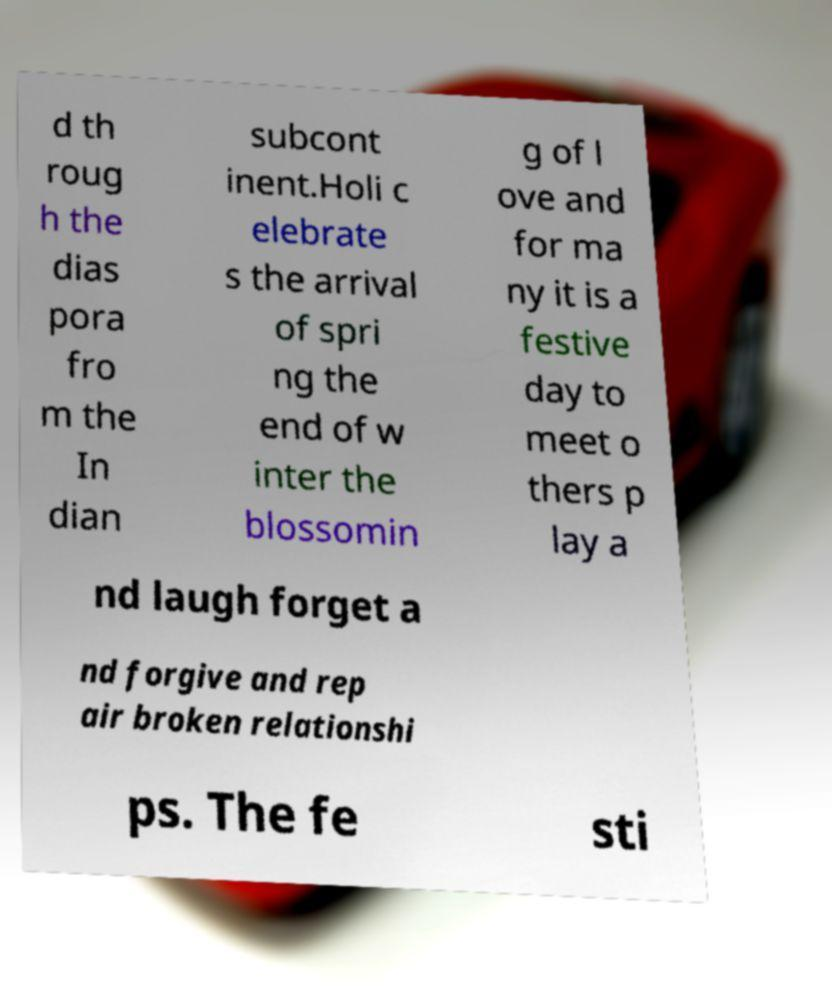I need the written content from this picture converted into text. Can you do that? d th roug h the dias pora fro m the In dian subcont inent.Holi c elebrate s the arrival of spri ng the end of w inter the blossomin g of l ove and for ma ny it is a festive day to meet o thers p lay a nd laugh forget a nd forgive and rep air broken relationshi ps. The fe sti 